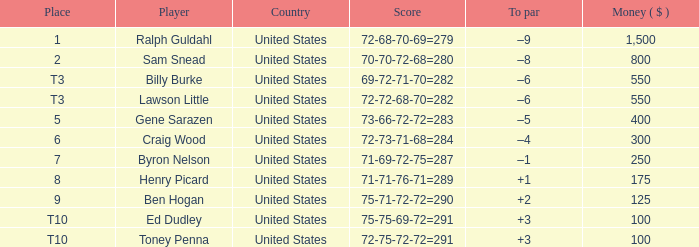Could you parse the entire table? {'header': ['Place', 'Player', 'Country', 'Score', 'To par', 'Money ( $ )'], 'rows': [['1', 'Ralph Guldahl', 'United States', '72-68-70-69=279', '–9', '1,500'], ['2', 'Sam Snead', 'United States', '70-70-72-68=280', '–8', '800'], ['T3', 'Billy Burke', 'United States', '69-72-71-70=282', '–6', '550'], ['T3', 'Lawson Little', 'United States', '72-72-68-70=282', '–6', '550'], ['5', 'Gene Sarazen', 'United States', '73-66-72-72=283', '–5', '400'], ['6', 'Craig Wood', 'United States', '72-73-71-68=284', '–4', '300'], ['7', 'Byron Nelson', 'United States', '71-69-72-75=287', '–1', '250'], ['8', 'Henry Picard', 'United States', '71-71-76-71=289', '+1', '175'], ['9', 'Ben Hogan', 'United States', '75-71-72-72=290', '+2', '125'], ['T10', 'Ed Dudley', 'United States', '75-75-69-72=291', '+3', '100'], ['T10', 'Toney Penna', 'United States', '72-75-72-72=291', '+3', '100']]} Which country has a prize smaller than $250 and the player Henry Picard? United States. 